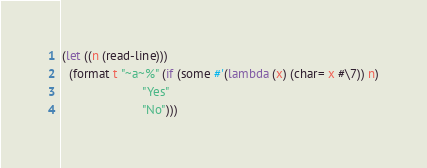<code> <loc_0><loc_0><loc_500><loc_500><_Lisp_>(let ((n (read-line)))
  (format t "~a~%" (if (some #'(lambda (x) (char= x #\7)) n)
                       "Yes"
                       "No")))
</code> 